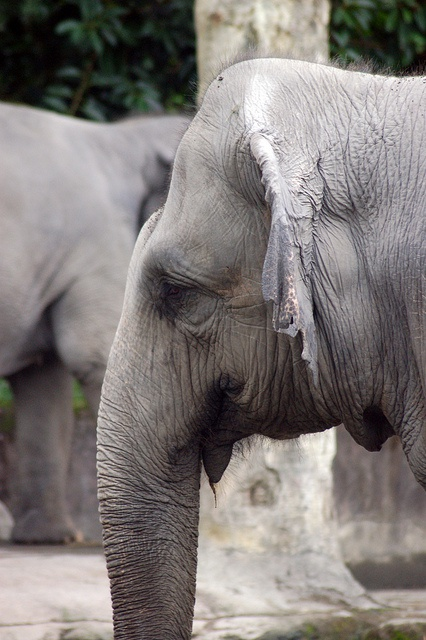Describe the objects in this image and their specific colors. I can see elephant in black, gray, darkgray, and lightgray tones and elephant in black, darkgray, gray, and lightgray tones in this image. 